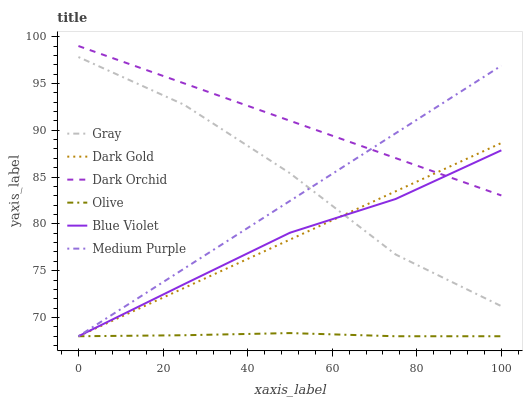Does Olive have the minimum area under the curve?
Answer yes or no. Yes. Does Dark Orchid have the maximum area under the curve?
Answer yes or no. Yes. Does Dark Gold have the minimum area under the curve?
Answer yes or no. No. Does Dark Gold have the maximum area under the curve?
Answer yes or no. No. Is Dark Gold the smoothest?
Answer yes or no. Yes. Is Gray the roughest?
Answer yes or no. Yes. Is Dark Orchid the smoothest?
Answer yes or no. No. Is Dark Orchid the roughest?
Answer yes or no. No. Does Dark Gold have the lowest value?
Answer yes or no. Yes. Does Dark Orchid have the lowest value?
Answer yes or no. No. Does Dark Orchid have the highest value?
Answer yes or no. Yes. Does Dark Gold have the highest value?
Answer yes or no. No. Is Olive less than Dark Orchid?
Answer yes or no. Yes. Is Dark Orchid greater than Olive?
Answer yes or no. Yes. Does Dark Gold intersect Medium Purple?
Answer yes or no. Yes. Is Dark Gold less than Medium Purple?
Answer yes or no. No. Is Dark Gold greater than Medium Purple?
Answer yes or no. No. Does Olive intersect Dark Orchid?
Answer yes or no. No. 